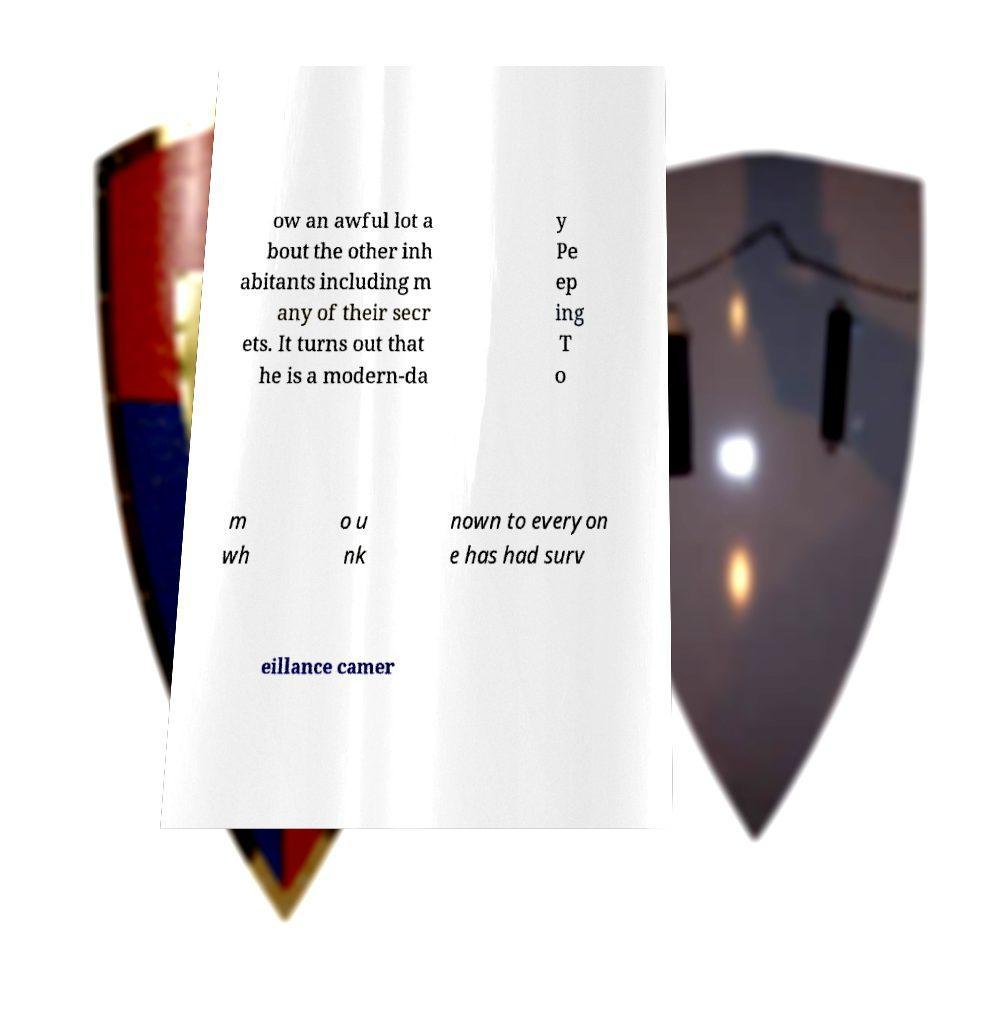There's text embedded in this image that I need extracted. Can you transcribe it verbatim? ow an awful lot a bout the other inh abitants including m any of their secr ets. It turns out that he is a modern-da y Pe ep ing T o m wh o u nk nown to everyon e has had surv eillance camer 